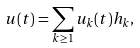Convert formula to latex. <formula><loc_0><loc_0><loc_500><loc_500>u ( t ) = \sum _ { k \geq 1 } u _ { k } ( t ) h _ { k } ,</formula> 